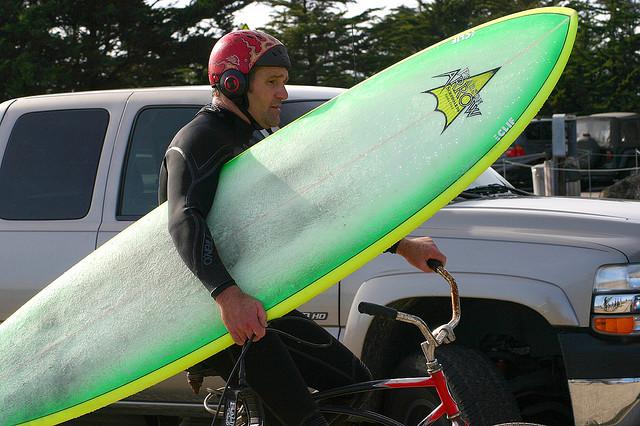What is the man wearing on this head?
Write a very short answer. Helmet. What is the surfer riding?
Write a very short answer. Bicycle. What color surfboard is he holding?
Quick response, please. Green. 